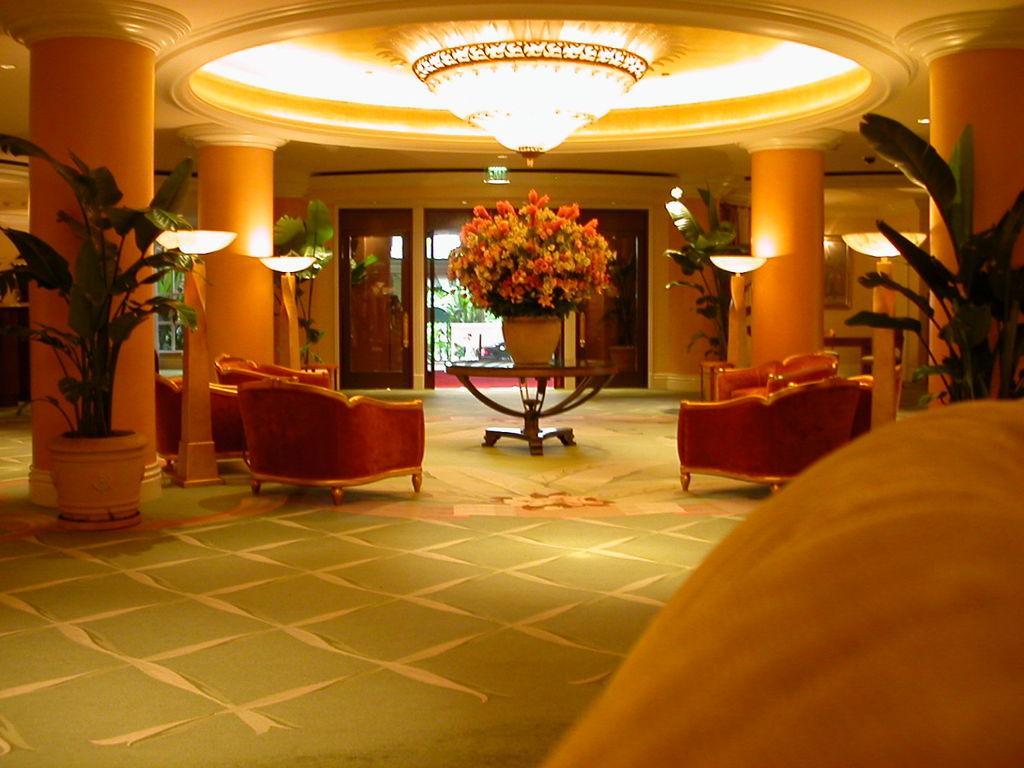Describe this image in one or two sentences. In this picture there are four chairs at the center of the image and some trees around the image and a decorative ceiling above the image it seems to be an entrance of a hotel which is highlighted with the lights and decorative pieces. 